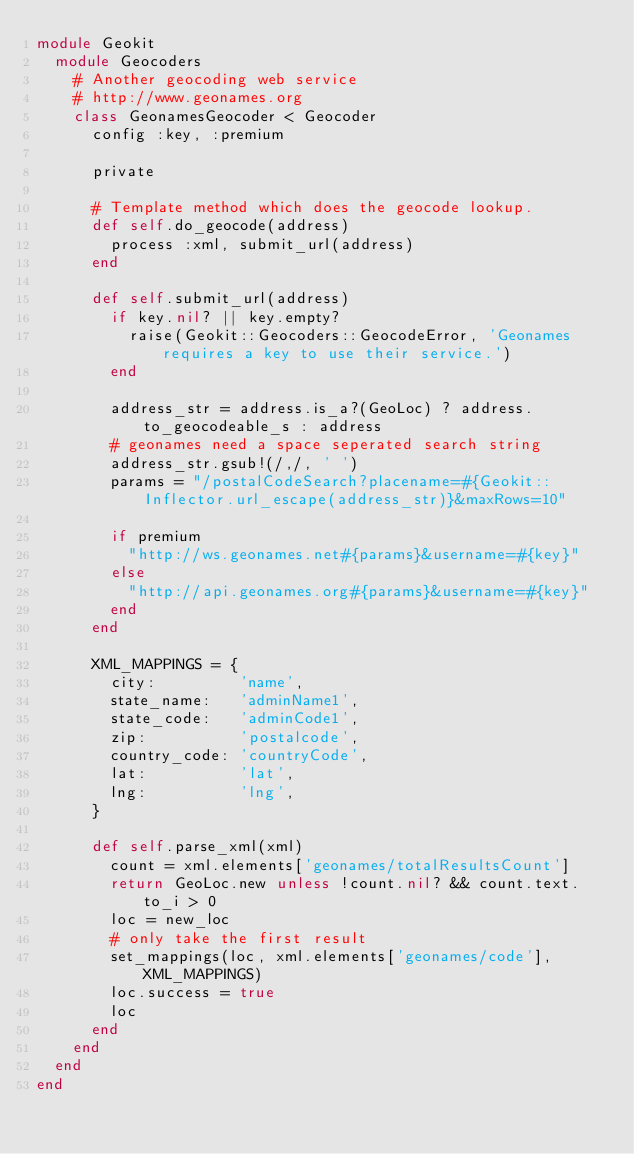Convert code to text. <code><loc_0><loc_0><loc_500><loc_500><_Ruby_>module Geokit
  module Geocoders
    # Another geocoding web service
    # http://www.geonames.org
    class GeonamesGeocoder < Geocoder
      config :key, :premium

      private

      # Template method which does the geocode lookup.
      def self.do_geocode(address)
        process :xml, submit_url(address)
      end

      def self.submit_url(address)
        if key.nil? || key.empty?
          raise(Geokit::Geocoders::GeocodeError, 'Geonames requires a key to use their service.')
        end

        address_str = address.is_a?(GeoLoc) ? address.to_geocodeable_s : address
        # geonames need a space seperated search string
        address_str.gsub!(/,/, ' ')
        params = "/postalCodeSearch?placename=#{Geokit::Inflector.url_escape(address_str)}&maxRows=10"

        if premium
          "http://ws.geonames.net#{params}&username=#{key}"
        else
          "http://api.geonames.org#{params}&username=#{key}"
        end
      end

      XML_MAPPINGS = {
        city:         'name',
        state_name:   'adminName1',
        state_code:   'adminCode1',
        zip:          'postalcode',
        country_code: 'countryCode',
        lat:          'lat',
        lng:          'lng',
      }

      def self.parse_xml(xml)
        count = xml.elements['geonames/totalResultsCount']
        return GeoLoc.new unless !count.nil? && count.text.to_i > 0
        loc = new_loc
        # only take the first result
        set_mappings(loc, xml.elements['geonames/code'], XML_MAPPINGS)
        loc.success = true
        loc
      end
    end
  end
end
</code> 